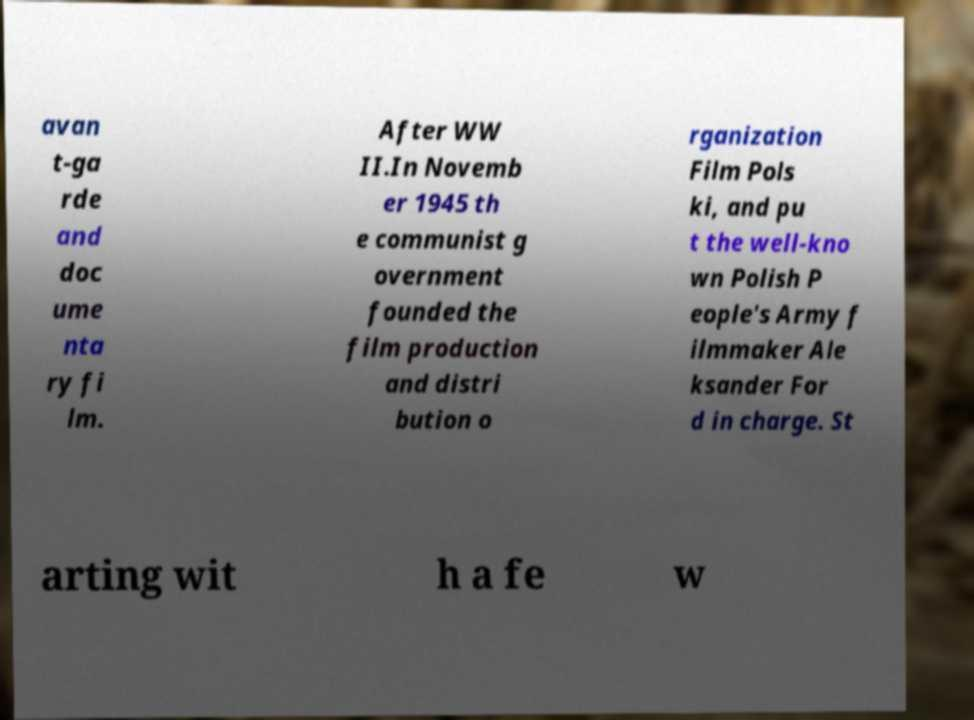There's text embedded in this image that I need extracted. Can you transcribe it verbatim? avan t-ga rde and doc ume nta ry fi lm. After WW II.In Novemb er 1945 th e communist g overnment founded the film production and distri bution o rganization Film Pols ki, and pu t the well-kno wn Polish P eople's Army f ilmmaker Ale ksander For d in charge. St arting wit h a fe w 